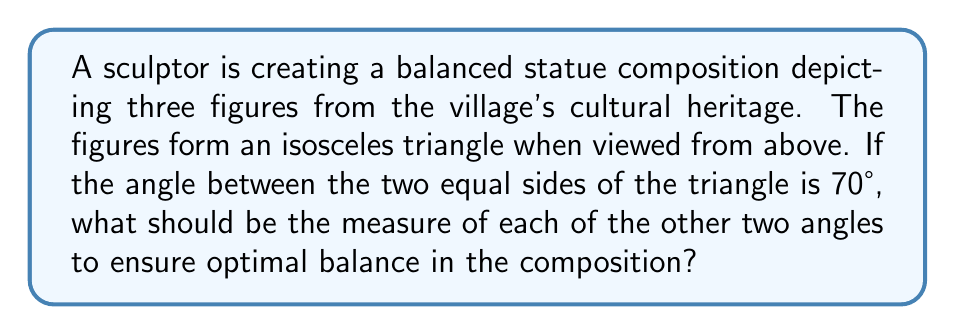What is the answer to this math problem? Let's approach this step-by-step:

1) In an isosceles triangle, two angles are equal, and the third angle (the one between the equal sides) is different.

2) We are given that the angle between the equal sides is 70°.

3) Let's call each of the other two angles $x°$.

4) We know that the sum of angles in a triangle is always 180°. So we can set up an equation:

   $$70° + x° + x° = 180°$$

5) Simplify:
   $$70° + 2x° = 180°$$

6) Subtract 70° from both sides:
   $$2x° = 110°$$

7) Divide both sides by 2:
   $$x° = 55°$$

8) Therefore, each of the other two angles should measure 55°.

9) We can verify:
   $$55° + 55° + 70° = 180°$$

This arrangement will ensure optimal balance in the composition, as the two equal angles will create symmetry in the statue's layout.
Answer: Each of the other two angles should measure 55°. 